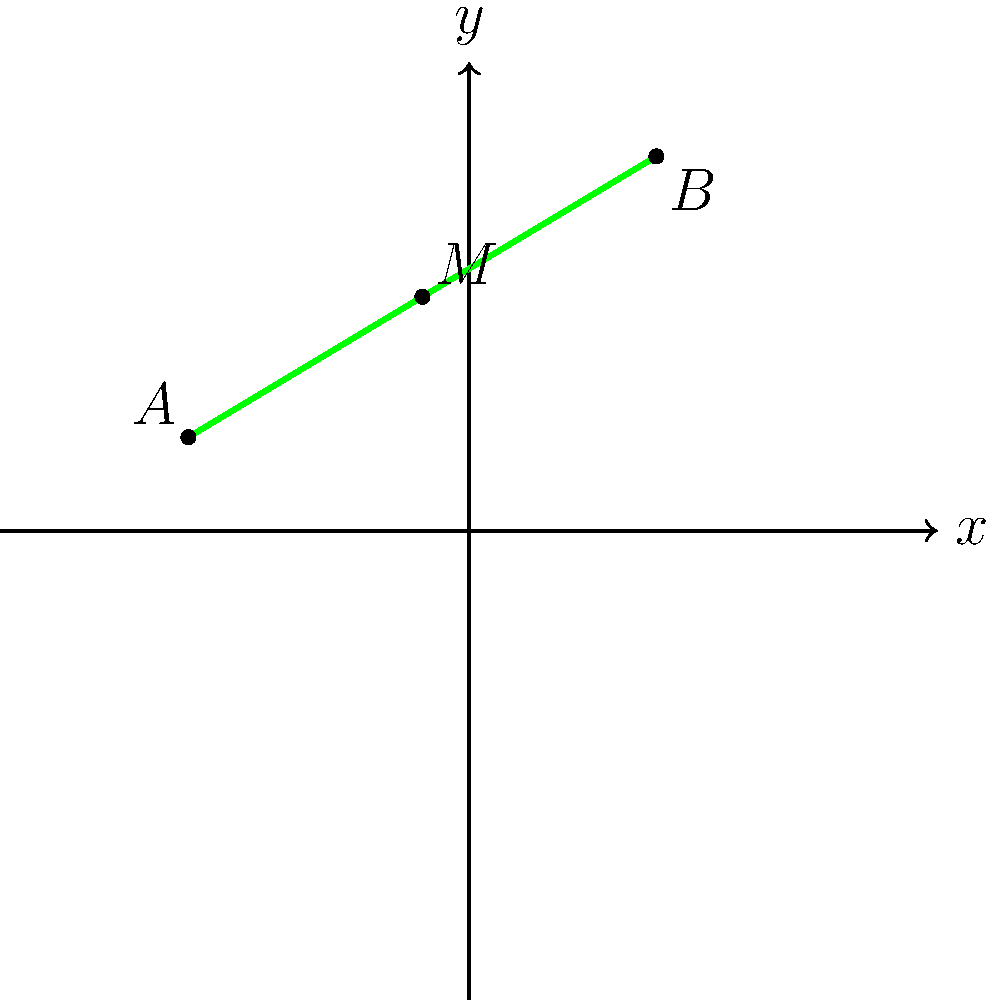At the famous Old Course in St Andrews, you're analyzing a particularly challenging fairway. On a coordinate plane, the fairway is represented by a line segment from point $A(-6, 2)$ to point $B(4, 8)$. To determine the best spot for placing a strategic bunker, you need to find the midpoint of this fairway. What are the coordinates of the midpoint $M$? To find the midpoint $M$ of the line segment $\overline{AB}$, we can use the midpoint formula:

$M = (\frac{x_1 + x_2}{2}, \frac{y_1 + y_2}{2})$

Where $(x_1, y_1)$ are the coordinates of point $A$, and $(x_2, y_2)$ are the coordinates of point $B$.

Given:
$A(-6, 2)$ and $B(4, 8)$

Step 1: Calculate the x-coordinate of the midpoint:
$x_M = \frac{x_1 + x_2}{2} = \frac{-6 + 4}{2} = \frac{-2}{2} = -1$

Step 2: Calculate the y-coordinate of the midpoint:
$y_M = \frac{y_1 + y_2}{2} = \frac{2 + 8}{2} = \frac{10}{2} = 5$

Therefore, the coordinates of the midpoint $M$ are $(-1, 5)$.
Answer: $(-1, 5)$ 